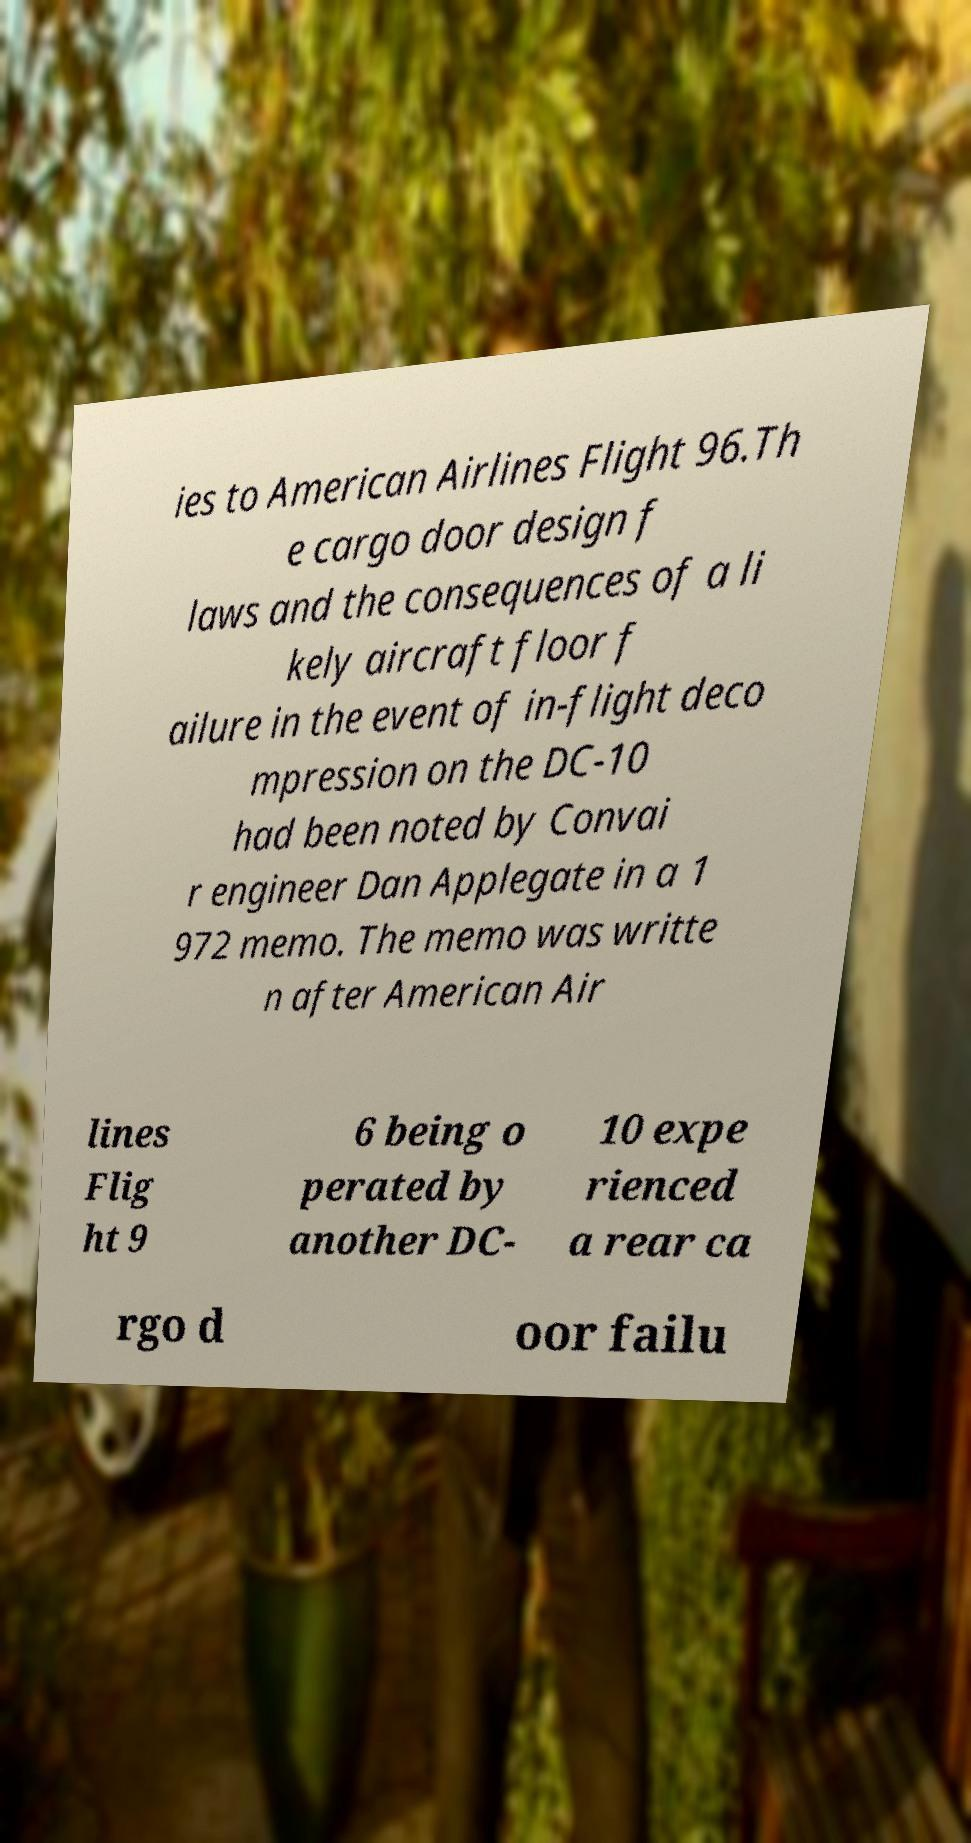Please read and relay the text visible in this image. What does it say? ies to American Airlines Flight 96.Th e cargo door design f laws and the consequences of a li kely aircraft floor f ailure in the event of in-flight deco mpression on the DC-10 had been noted by Convai r engineer Dan Applegate in a 1 972 memo. The memo was writte n after American Air lines Flig ht 9 6 being o perated by another DC- 10 expe rienced a rear ca rgo d oor failu 